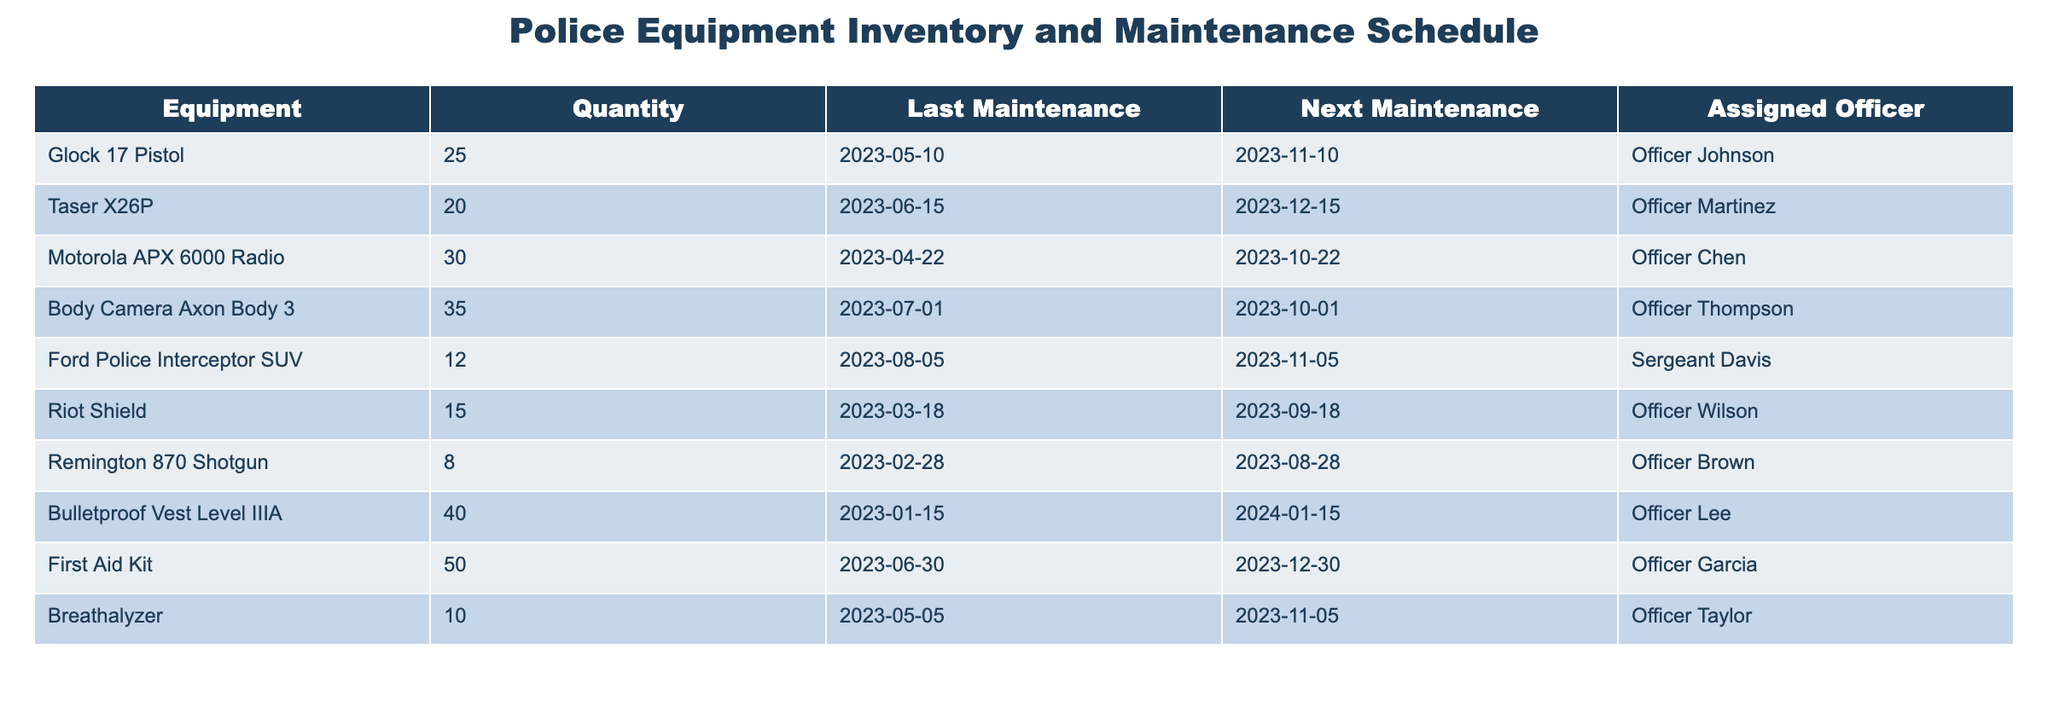What is the quantity of Body Camera Axon Body 3 in the inventory? The table lists the Body Camera Axon Body 3 under the Equipment column, and the corresponding quantity is found in the Quantity column. For Body Camera Axon Body 3, the quantity is 35.
Answer: 35 Who is assigned to maintain the Glock 17 Pistol? The Glock 17 Pistol is listed under the Equipment column, and the assigned officer is found in the Assigned Officer column. For the Glock 17 Pistol, Officer Johnson is the assigned officer.
Answer: Officer Johnson What date is the next maintenance scheduled for the Taser X26P? The Taser X26P is in the table, and the next maintenance date is provided in the Next Maintenance column. It shows that the next maintenance is scheduled for 2023-12-15.
Answer: 2023-12-15 How many pieces of equipment have a next maintenance date in November 2023? To find this, we look at the Next Maintenance column and count how many entries fall in November 2023. The relevant equipment are Glock 17 Pistol (2023-11-10), Ford Police Interceptor SUV (2023-11-05), and Breathalyzer (2023-11-05), totaling three pieces of equipment.
Answer: 3 Is there any equipment that has not been maintained since January 2023? We check the Last Maintenance column for any equipment with dates before January 2023. The only equipment that meets the criteria is the Bulletproof Vest Level IIIA, which had its last maintenance on 2023-01-15, so the answer is yes.
Answer: Yes What is the average quantity of equipment assigned to Officer Martinez and Officer Brown? First, we locate the quantities for Officer Martinez (Taser X26P, quantity 20) and Officer Brown (Remington 870 Shotgun, quantity 8). Then we calculate the average: (20 + 8) / 2 = 28 / 2 = 14.
Answer: 14 How many pieces of equipment are assigned to officers whose last names start with 'B' or 'L'? We look at the Assigned Officer column for last names starting with 'B' (Officer Brown) and 'L' (Officer Lee). The equipment assigned to them are Remington 870 Shotgun and Bulletproof Vest Level IIIA, respectively, giving a total of two pieces of equipment.
Answer: 2 Which piece of equipment has the highest quantity in the table? We need to identify the quantities for each piece of equipment and find the highest. The Bulletproof Vest Level IIIA has the highest quantity of 40 compared to others.
Answer: Bulletproof Vest Level IIIA What is the total quantity of equipment used for personal protection (Glock 17 Pistol, Taser X26P, and Bulletproof Vest Level IIIA)? We sum the quantities of the specified items: Glock 17 Pistol (25), Taser X26P (20), and Bulletproof Vest Level IIIA (40). Thus, the total quantity is 25 + 20 + 40 = 85.
Answer: 85 